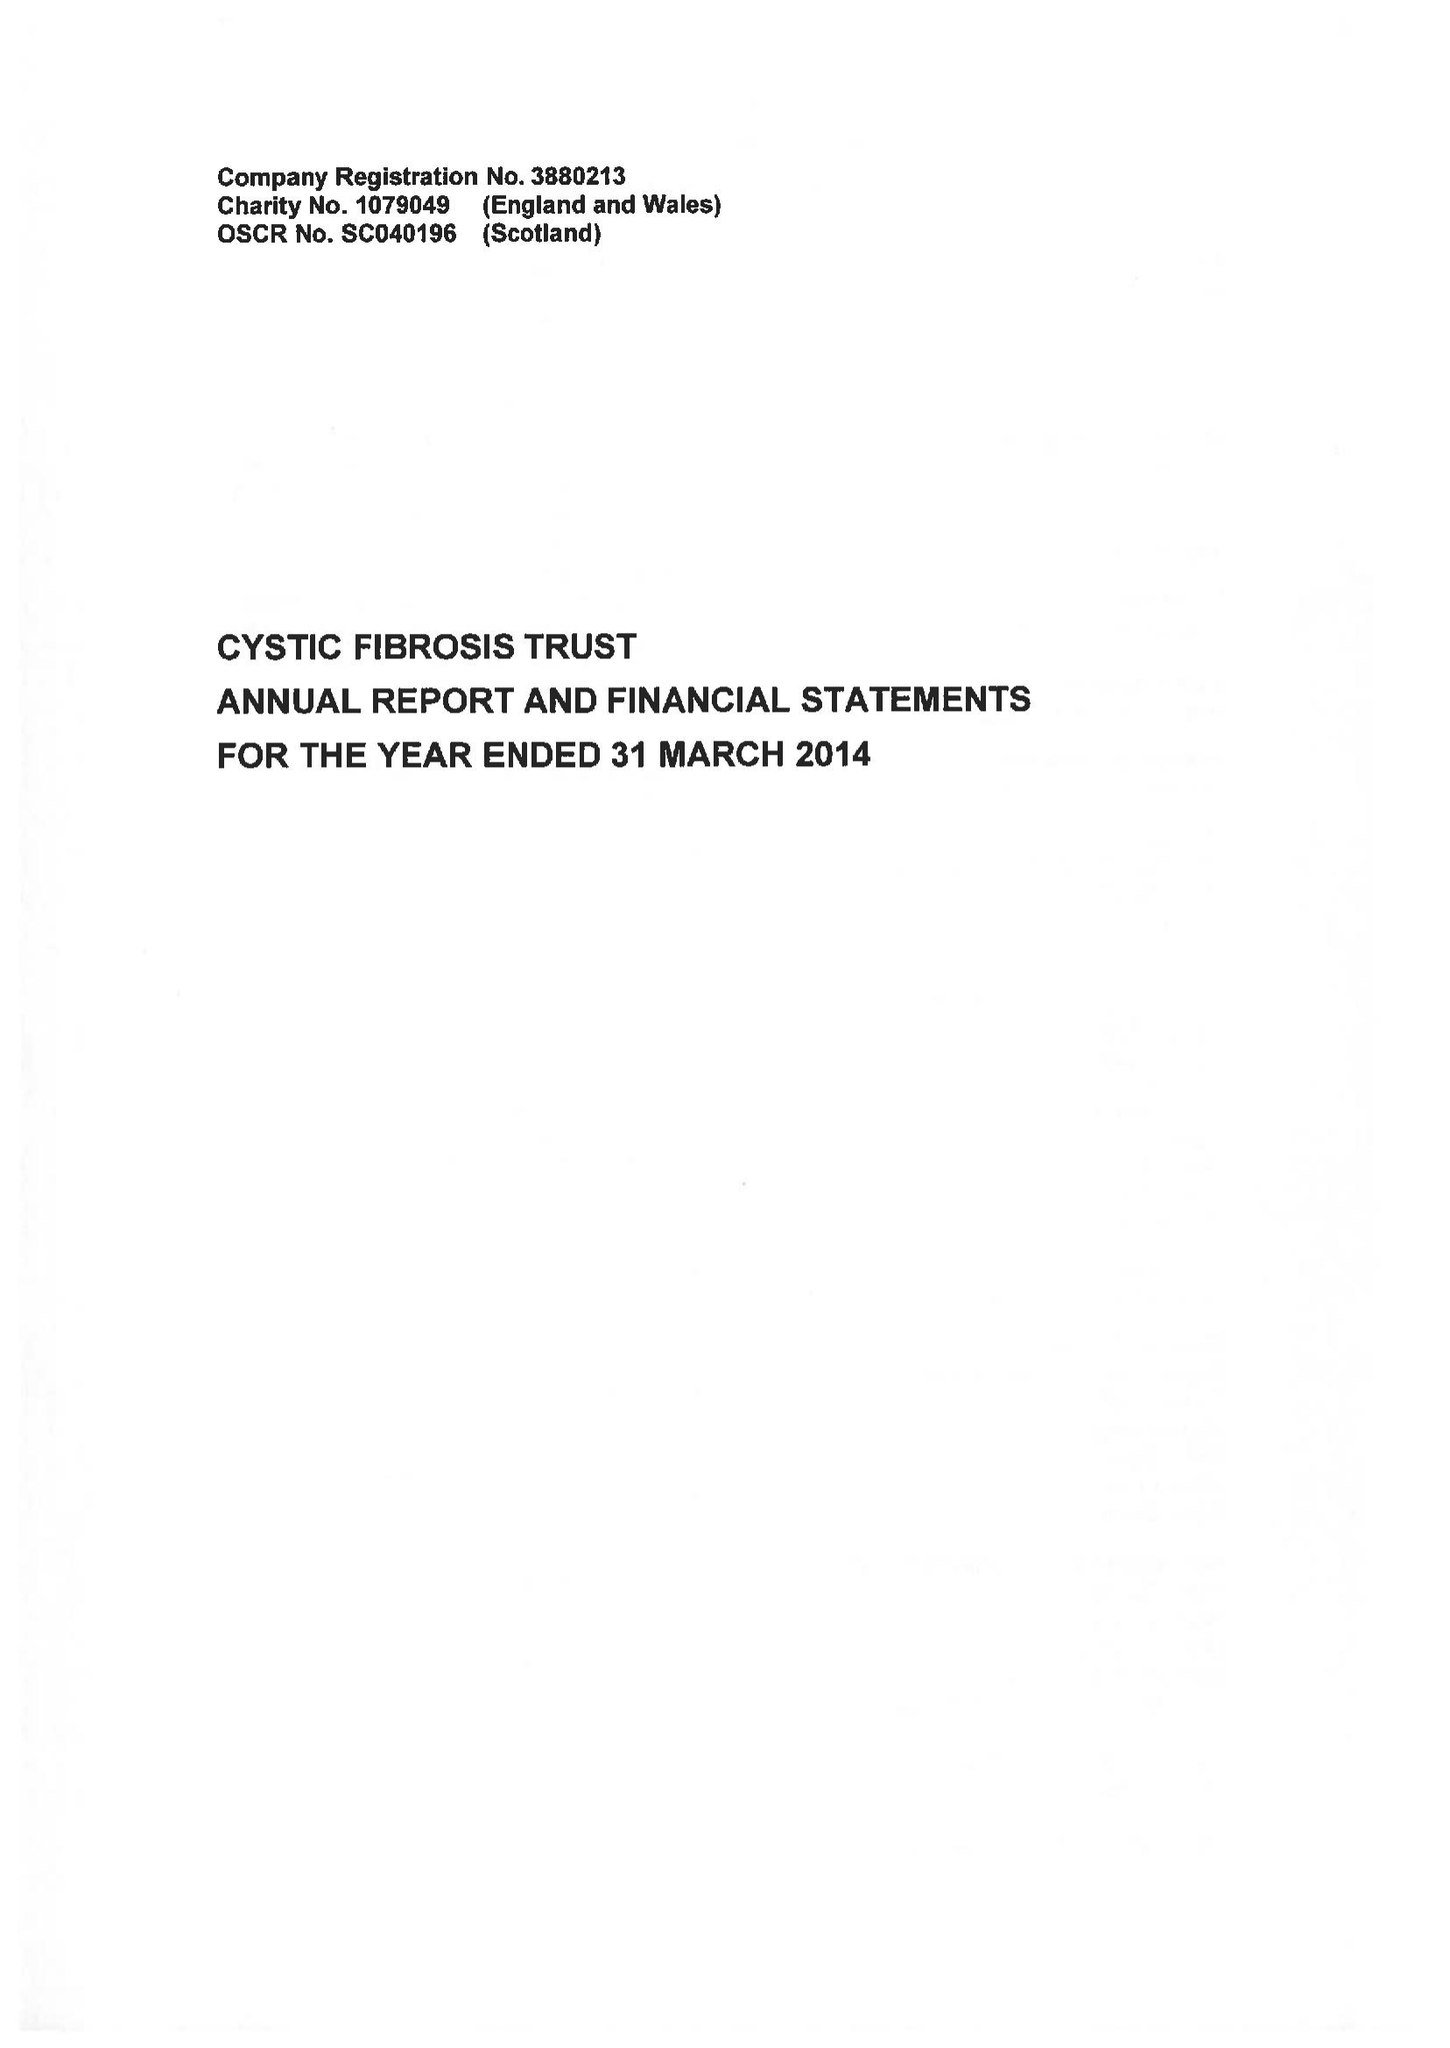What is the value for the address__street_line?
Answer the question using a single word or phrase. 1 ALDGATE 